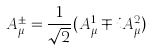Convert formula to latex. <formula><loc_0><loc_0><loc_500><loc_500>A _ { \mu } ^ { \pm } = \frac { 1 } { \sqrt { 2 } } ( A _ { \mu } ^ { 1 } \mp i A _ { \mu } ^ { 2 } )</formula> 